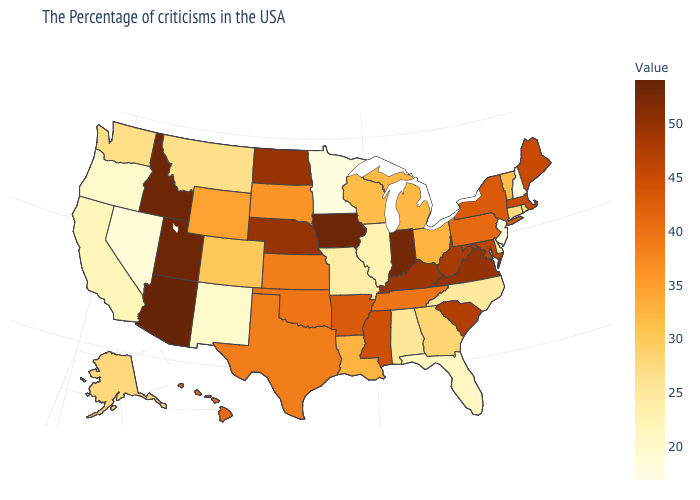Does Louisiana have the highest value in the USA?
Keep it brief. No. Which states have the lowest value in the USA?
Concise answer only. New Hampshire. Does Colorado have a lower value than Utah?
Concise answer only. Yes. Which states have the lowest value in the USA?
Short answer required. New Hampshire. 